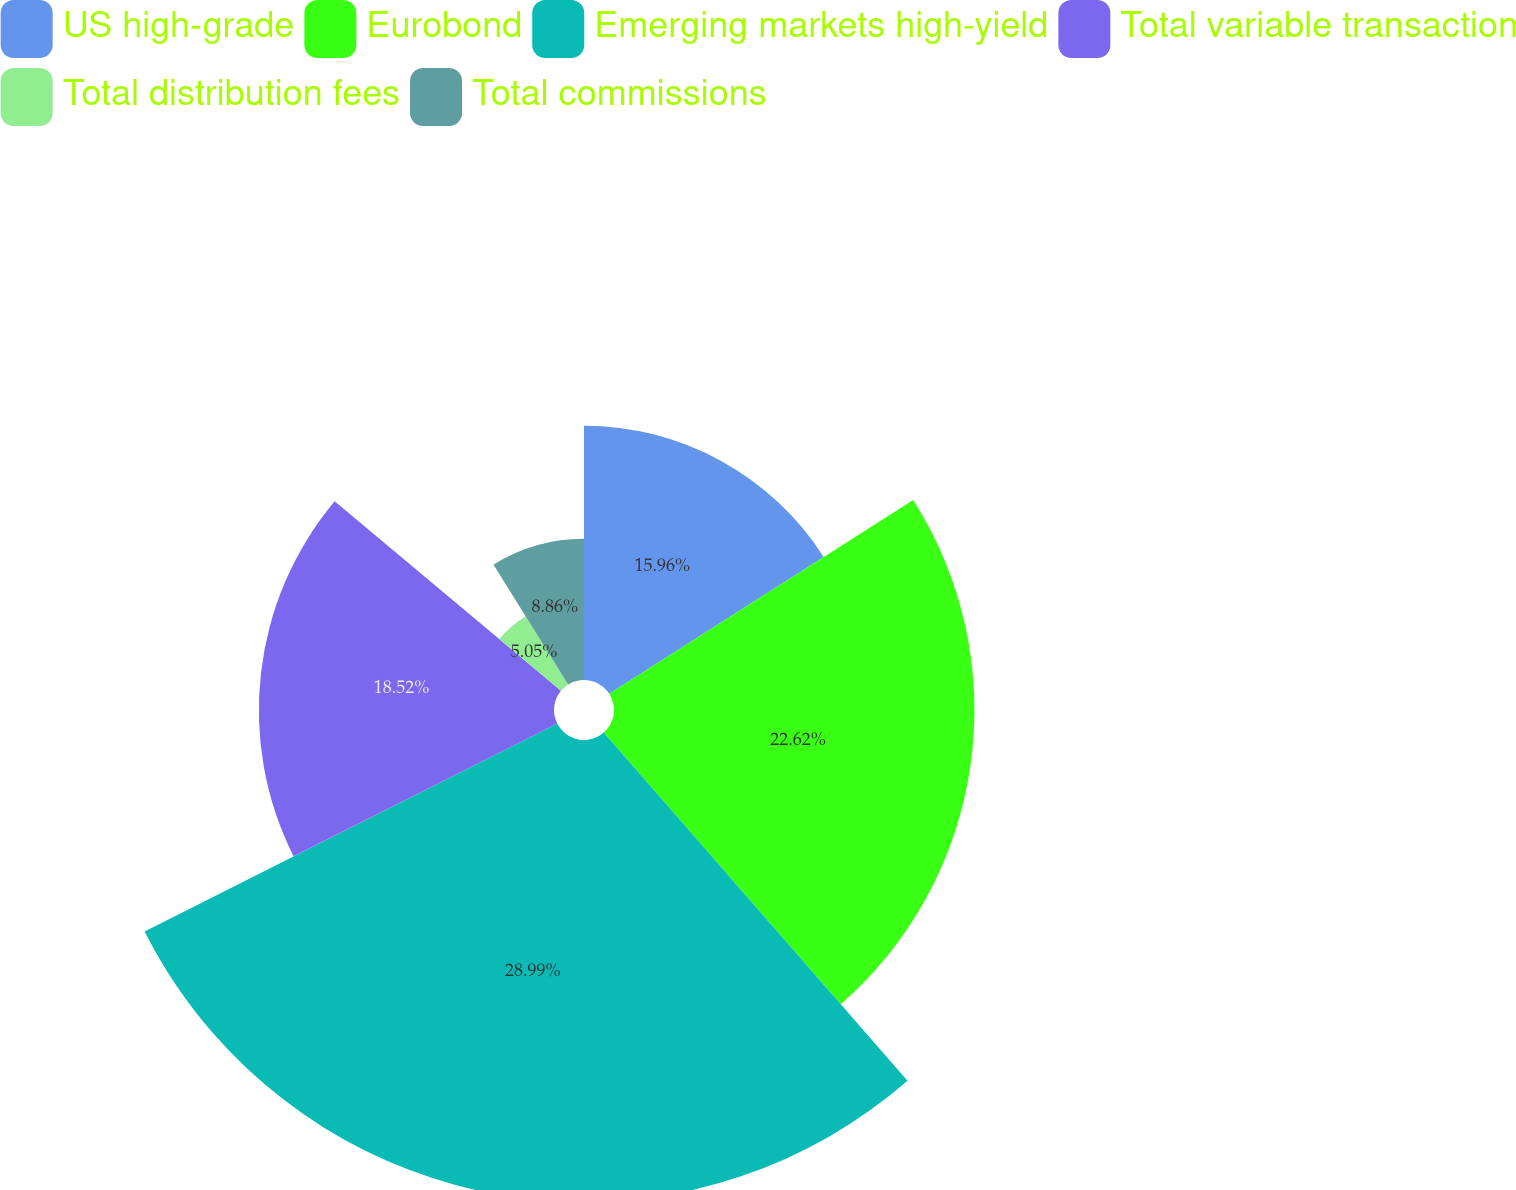Convert chart. <chart><loc_0><loc_0><loc_500><loc_500><pie_chart><fcel>US high-grade<fcel>Eurobond<fcel>Emerging markets high-yield<fcel>Total variable transaction<fcel>Total distribution fees<fcel>Total commissions<nl><fcel>15.96%<fcel>22.62%<fcel>28.99%<fcel>18.52%<fcel>5.05%<fcel>8.86%<nl></chart> 